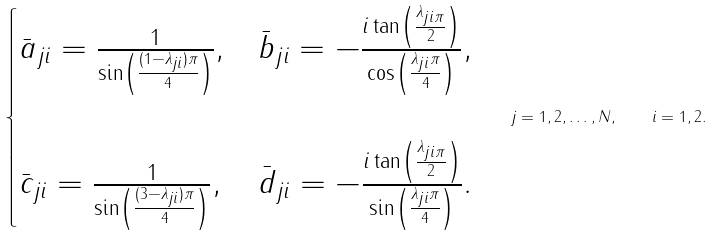<formula> <loc_0><loc_0><loc_500><loc_500>\begin{cases} \bar { a } _ { j i } = \frac { 1 } { \sin \left ( \frac { ( 1 - \lambda _ { j i } ) \pi } { 4 } \right ) } , & \bar { b } _ { j i } = - \frac { i \tan \left ( \frac { \lambda _ { j i \pi } } { 2 } \right ) } { \cos \left ( \frac { \lambda _ { j i } \pi } { 4 } \right ) } , \\ \\ \bar { c } _ { j i } = \frac { 1 } { \sin \left ( \frac { ( 3 - \lambda _ { j i } ) \pi } { 4 } \right ) } , & \bar { d } _ { j i } = - \frac { i \tan \left ( \frac { \lambda _ { j i \pi } } { 2 } \right ) } { \sin \left ( \frac { \lambda _ { j i } \pi } { 4 } \right ) } . \end{cases} \quad j = 1 , 2 , \dots , N , \quad i = 1 , 2 .</formula> 